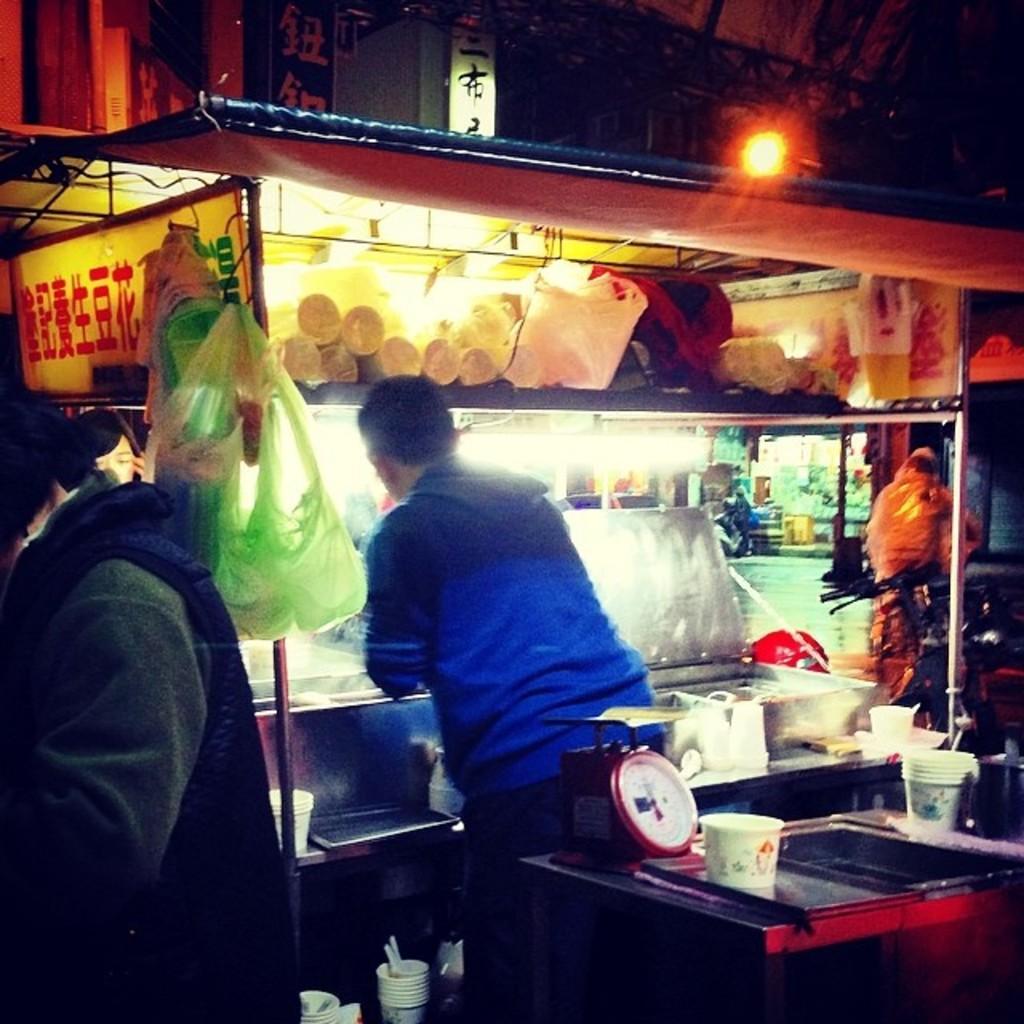In one or two sentences, can you explain what this image depicts? In this image there are stalls, boards, light, plastic bags, people, weighing machine, table, cups and objects. 